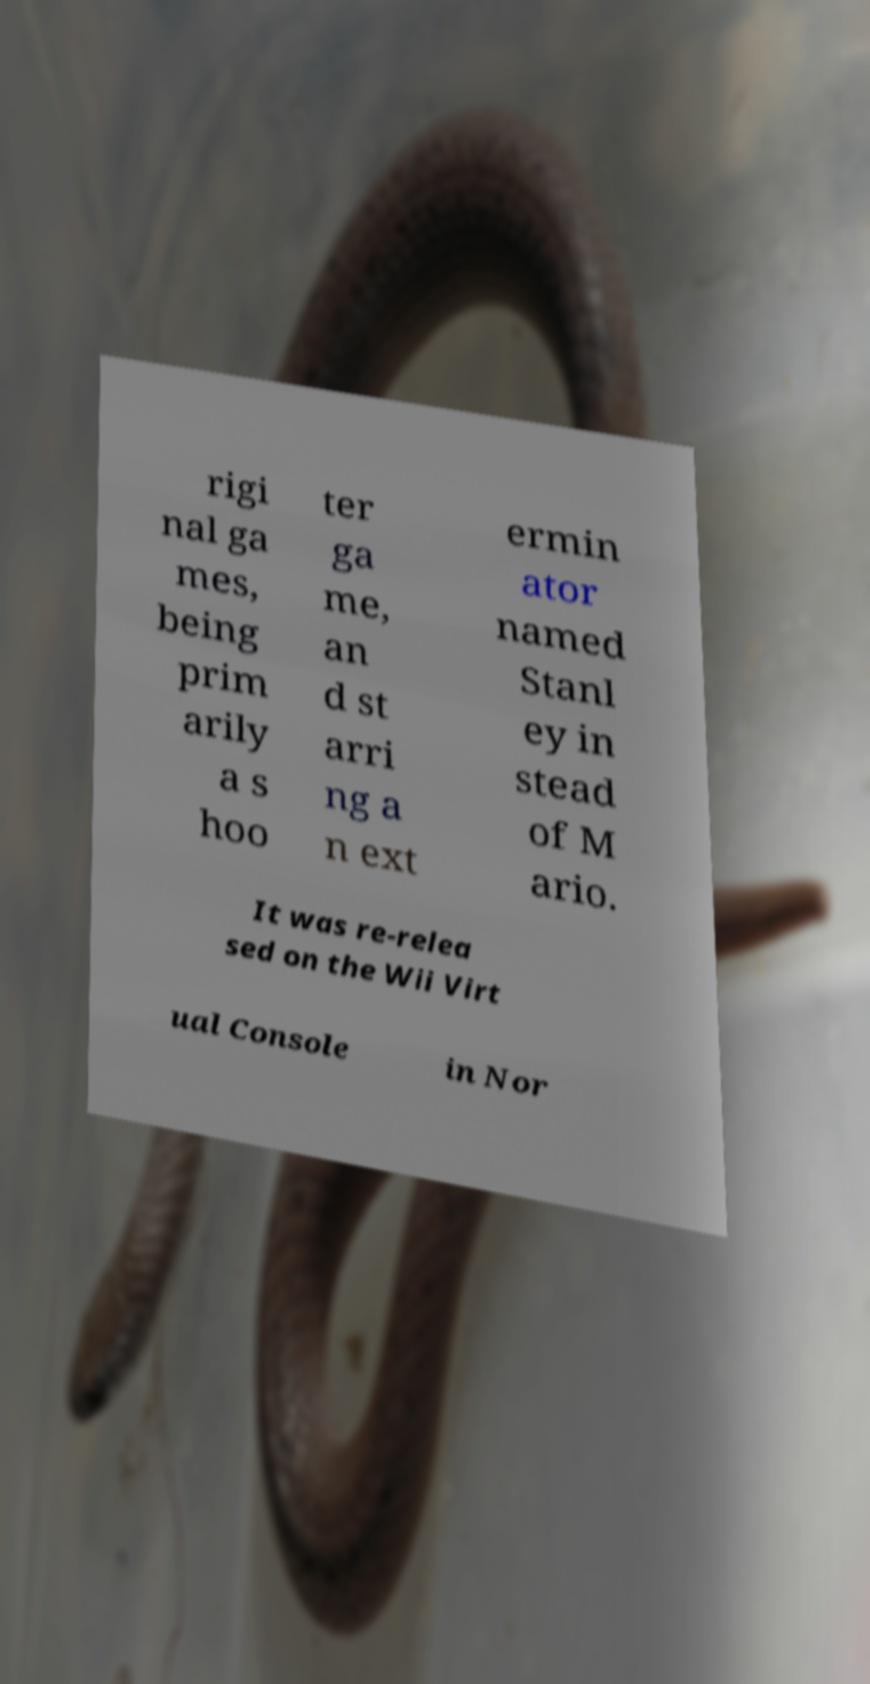Could you extract and type out the text from this image? rigi nal ga mes, being prim arily a s hoo ter ga me, an d st arri ng a n ext ermin ator named Stanl ey in stead of M ario. It was re-relea sed on the Wii Virt ual Console in Nor 